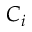<formula> <loc_0><loc_0><loc_500><loc_500>C _ { i }</formula> 